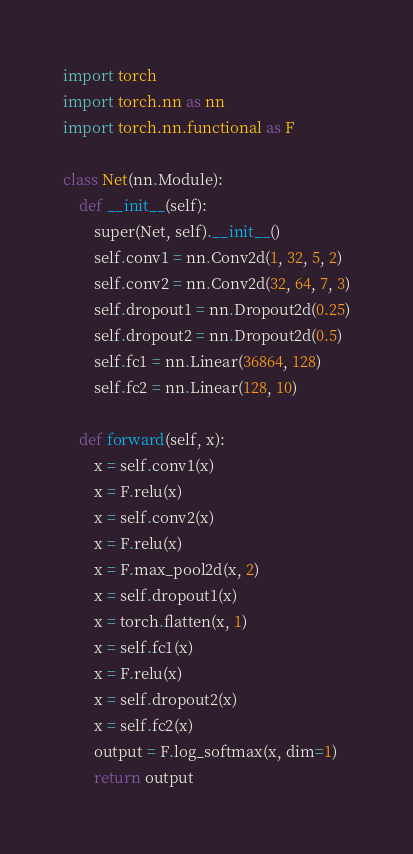Convert code to text. <code><loc_0><loc_0><loc_500><loc_500><_Python_>import torch
import torch.nn as nn
import torch.nn.functional as F

class Net(nn.Module):
    def __init__(self):
        super(Net, self).__init__()
        self.conv1 = nn.Conv2d(1, 32, 5, 2)
        self.conv2 = nn.Conv2d(32, 64, 7, 3)
        self.dropout1 = nn.Dropout2d(0.25)
        self.dropout2 = nn.Dropout2d(0.5)
        self.fc1 = nn.Linear(36864, 128)
        self.fc2 = nn.Linear(128, 10)

    def forward(self, x):
        x = self.conv1(x)
        x = F.relu(x)
        x = self.conv2(x)
        x = F.relu(x)
        x = F.max_pool2d(x, 2)
        x = self.dropout1(x)
        x = torch.flatten(x, 1)
        x = self.fc1(x)
        x = F.relu(x)
        x = self.dropout2(x)
        x = self.fc2(x)
        output = F.log_softmax(x, dim=1)
        return output
</code> 